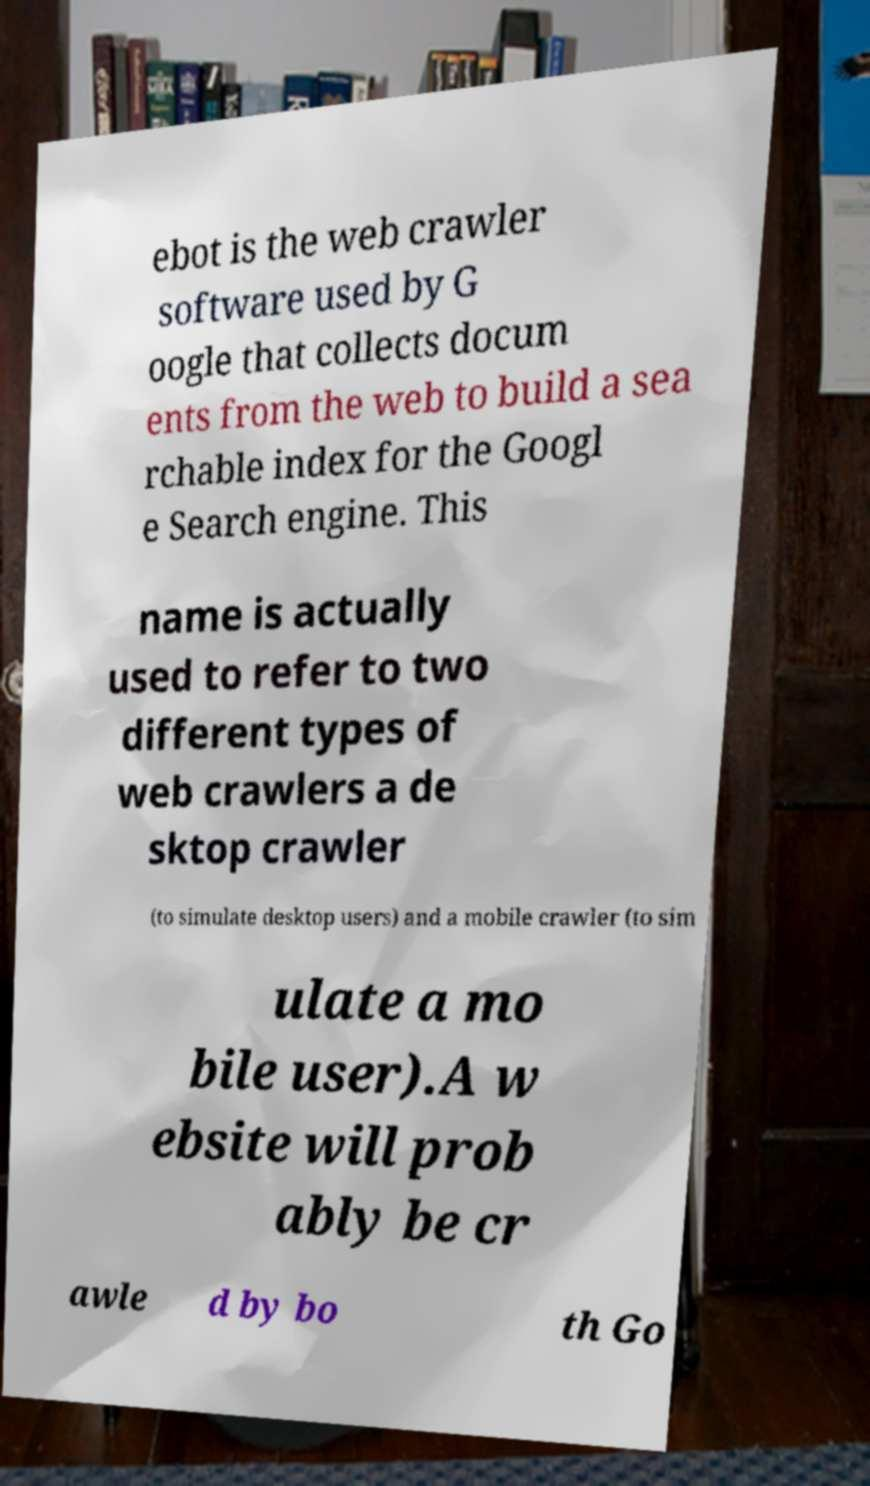Could you assist in decoding the text presented in this image and type it out clearly? ebot is the web crawler software used by G oogle that collects docum ents from the web to build a sea rchable index for the Googl e Search engine. This name is actually used to refer to two different types of web crawlers a de sktop crawler (to simulate desktop users) and a mobile crawler (to sim ulate a mo bile user).A w ebsite will prob ably be cr awle d by bo th Go 